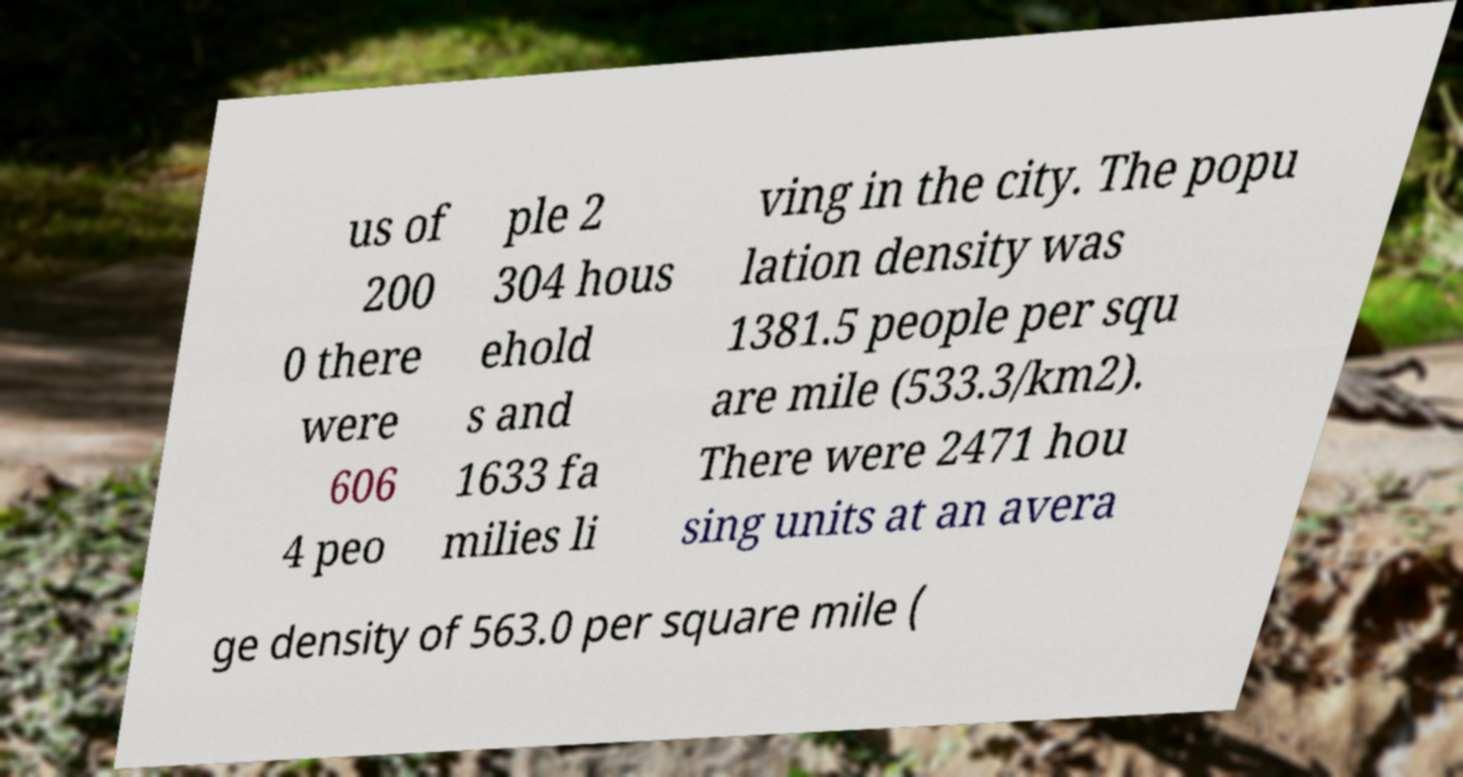Could you extract and type out the text from this image? us of 200 0 there were 606 4 peo ple 2 304 hous ehold s and 1633 fa milies li ving in the city. The popu lation density was 1381.5 people per squ are mile (533.3/km2). There were 2471 hou sing units at an avera ge density of 563.0 per square mile ( 